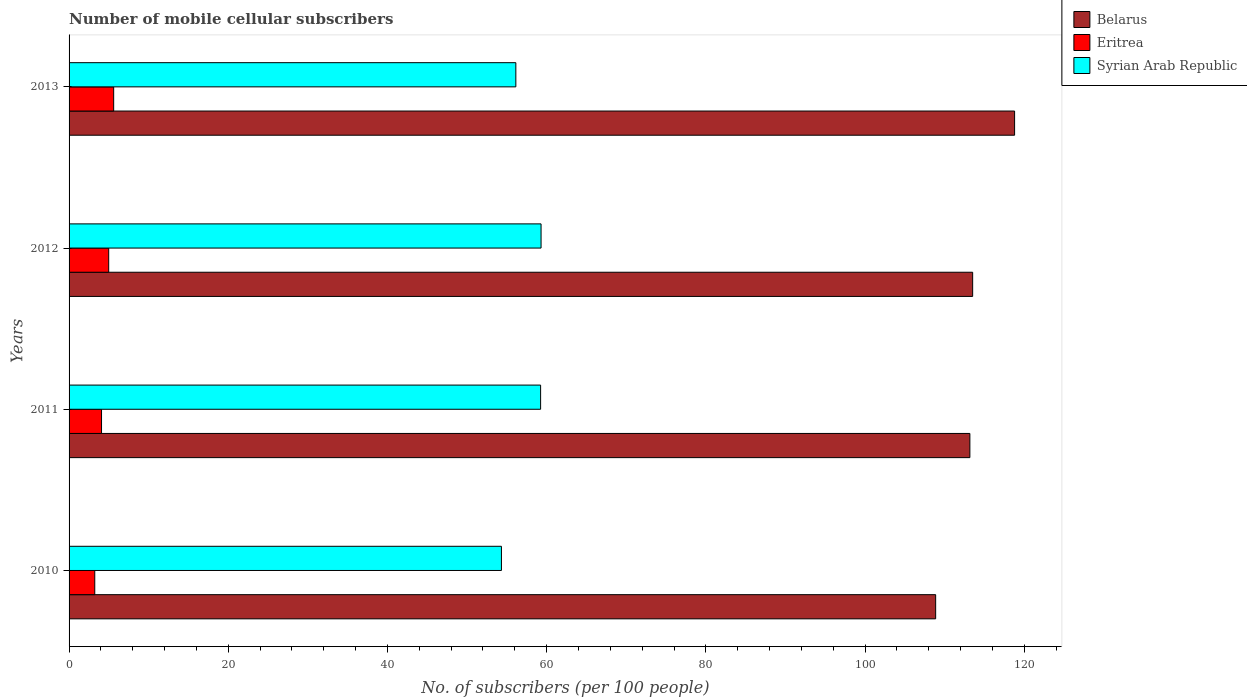How many groups of bars are there?
Offer a terse response. 4. Are the number of bars on each tick of the Y-axis equal?
Keep it short and to the point. Yes. How many bars are there on the 1st tick from the top?
Your answer should be very brief. 3. What is the label of the 3rd group of bars from the top?
Offer a terse response. 2011. What is the number of mobile cellular subscribers in Eritrea in 2012?
Your response must be concise. 4.98. Across all years, what is the maximum number of mobile cellular subscribers in Eritrea?
Ensure brevity in your answer.  5.6. Across all years, what is the minimum number of mobile cellular subscribers in Eritrea?
Keep it short and to the point. 3.23. In which year was the number of mobile cellular subscribers in Belarus minimum?
Ensure brevity in your answer.  2010. What is the total number of mobile cellular subscribers in Eritrea in the graph?
Your answer should be very brief. 17.89. What is the difference between the number of mobile cellular subscribers in Eritrea in 2010 and that in 2011?
Give a very brief answer. -0.85. What is the difference between the number of mobile cellular subscribers in Eritrea in 2011 and the number of mobile cellular subscribers in Belarus in 2013?
Offer a very short reply. -114.71. What is the average number of mobile cellular subscribers in Syrian Arab Republic per year?
Your answer should be compact. 57.25. In the year 2012, what is the difference between the number of mobile cellular subscribers in Belarus and number of mobile cellular subscribers in Syrian Arab Republic?
Offer a very short reply. 54.22. What is the ratio of the number of mobile cellular subscribers in Eritrea in 2010 to that in 2013?
Offer a terse response. 0.58. Is the number of mobile cellular subscribers in Belarus in 2010 less than that in 2011?
Provide a short and direct response. Yes. What is the difference between the highest and the second highest number of mobile cellular subscribers in Eritrea?
Ensure brevity in your answer.  0.62. What is the difference between the highest and the lowest number of mobile cellular subscribers in Syrian Arab Republic?
Offer a terse response. 4.98. In how many years, is the number of mobile cellular subscribers in Syrian Arab Republic greater than the average number of mobile cellular subscribers in Syrian Arab Republic taken over all years?
Your answer should be very brief. 2. What does the 2nd bar from the top in 2013 represents?
Provide a succinct answer. Eritrea. What does the 1st bar from the bottom in 2011 represents?
Ensure brevity in your answer.  Belarus. What is the difference between two consecutive major ticks on the X-axis?
Offer a very short reply. 20. Does the graph contain any zero values?
Keep it short and to the point. No. How are the legend labels stacked?
Offer a very short reply. Vertical. What is the title of the graph?
Your answer should be compact. Number of mobile cellular subscribers. What is the label or title of the X-axis?
Give a very brief answer. No. of subscribers (per 100 people). What is the No. of subscribers (per 100 people) in Belarus in 2010?
Make the answer very short. 108.87. What is the No. of subscribers (per 100 people) of Eritrea in 2010?
Offer a very short reply. 3.23. What is the No. of subscribers (per 100 people) in Syrian Arab Republic in 2010?
Make the answer very short. 54.32. What is the No. of subscribers (per 100 people) in Belarus in 2011?
Your answer should be very brief. 113.17. What is the No. of subscribers (per 100 people) of Eritrea in 2011?
Provide a succinct answer. 4.08. What is the No. of subscribers (per 100 people) in Syrian Arab Republic in 2011?
Offer a terse response. 59.24. What is the No. of subscribers (per 100 people) of Belarus in 2012?
Your answer should be very brief. 113.52. What is the No. of subscribers (per 100 people) in Eritrea in 2012?
Make the answer very short. 4.98. What is the No. of subscribers (per 100 people) of Syrian Arab Republic in 2012?
Give a very brief answer. 59.3. What is the No. of subscribers (per 100 people) of Belarus in 2013?
Provide a succinct answer. 118.79. What is the No. of subscribers (per 100 people) of Eritrea in 2013?
Provide a short and direct response. 5.6. What is the No. of subscribers (per 100 people) of Syrian Arab Republic in 2013?
Offer a terse response. 56.13. Across all years, what is the maximum No. of subscribers (per 100 people) in Belarus?
Give a very brief answer. 118.79. Across all years, what is the maximum No. of subscribers (per 100 people) of Eritrea?
Your response must be concise. 5.6. Across all years, what is the maximum No. of subscribers (per 100 people) in Syrian Arab Republic?
Your response must be concise. 59.3. Across all years, what is the minimum No. of subscribers (per 100 people) of Belarus?
Give a very brief answer. 108.87. Across all years, what is the minimum No. of subscribers (per 100 people) of Eritrea?
Provide a succinct answer. 3.23. Across all years, what is the minimum No. of subscribers (per 100 people) in Syrian Arab Republic?
Your answer should be compact. 54.32. What is the total No. of subscribers (per 100 people) of Belarus in the graph?
Keep it short and to the point. 454.34. What is the total No. of subscribers (per 100 people) of Eritrea in the graph?
Offer a terse response. 17.89. What is the total No. of subscribers (per 100 people) of Syrian Arab Republic in the graph?
Give a very brief answer. 228.98. What is the difference between the No. of subscribers (per 100 people) in Belarus in 2010 and that in 2011?
Provide a succinct answer. -4.3. What is the difference between the No. of subscribers (per 100 people) of Eritrea in 2010 and that in 2011?
Ensure brevity in your answer.  -0.85. What is the difference between the No. of subscribers (per 100 people) of Syrian Arab Republic in 2010 and that in 2011?
Offer a very short reply. -4.92. What is the difference between the No. of subscribers (per 100 people) of Belarus in 2010 and that in 2012?
Make the answer very short. -4.65. What is the difference between the No. of subscribers (per 100 people) in Eritrea in 2010 and that in 2012?
Offer a very short reply. -1.75. What is the difference between the No. of subscribers (per 100 people) of Syrian Arab Republic in 2010 and that in 2012?
Offer a very short reply. -4.98. What is the difference between the No. of subscribers (per 100 people) in Belarus in 2010 and that in 2013?
Your answer should be compact. -9.92. What is the difference between the No. of subscribers (per 100 people) of Eritrea in 2010 and that in 2013?
Your response must be concise. -2.38. What is the difference between the No. of subscribers (per 100 people) in Syrian Arab Republic in 2010 and that in 2013?
Your answer should be compact. -1.81. What is the difference between the No. of subscribers (per 100 people) of Belarus in 2011 and that in 2012?
Offer a terse response. -0.35. What is the difference between the No. of subscribers (per 100 people) in Eritrea in 2011 and that in 2012?
Provide a succinct answer. -0.9. What is the difference between the No. of subscribers (per 100 people) in Syrian Arab Republic in 2011 and that in 2012?
Your answer should be very brief. -0.06. What is the difference between the No. of subscribers (per 100 people) in Belarus in 2011 and that in 2013?
Your response must be concise. -5.62. What is the difference between the No. of subscribers (per 100 people) in Eritrea in 2011 and that in 2013?
Offer a terse response. -1.52. What is the difference between the No. of subscribers (per 100 people) of Syrian Arab Republic in 2011 and that in 2013?
Your answer should be compact. 3.11. What is the difference between the No. of subscribers (per 100 people) of Belarus in 2012 and that in 2013?
Your answer should be very brief. -5.27. What is the difference between the No. of subscribers (per 100 people) in Eritrea in 2012 and that in 2013?
Your response must be concise. -0.62. What is the difference between the No. of subscribers (per 100 people) in Syrian Arab Republic in 2012 and that in 2013?
Provide a short and direct response. 3.17. What is the difference between the No. of subscribers (per 100 people) in Belarus in 2010 and the No. of subscribers (per 100 people) in Eritrea in 2011?
Your answer should be very brief. 104.79. What is the difference between the No. of subscribers (per 100 people) of Belarus in 2010 and the No. of subscribers (per 100 people) of Syrian Arab Republic in 2011?
Keep it short and to the point. 49.63. What is the difference between the No. of subscribers (per 100 people) in Eritrea in 2010 and the No. of subscribers (per 100 people) in Syrian Arab Republic in 2011?
Offer a very short reply. -56.01. What is the difference between the No. of subscribers (per 100 people) of Belarus in 2010 and the No. of subscribers (per 100 people) of Eritrea in 2012?
Provide a short and direct response. 103.89. What is the difference between the No. of subscribers (per 100 people) in Belarus in 2010 and the No. of subscribers (per 100 people) in Syrian Arab Republic in 2012?
Provide a succinct answer. 49.57. What is the difference between the No. of subscribers (per 100 people) in Eritrea in 2010 and the No. of subscribers (per 100 people) in Syrian Arab Republic in 2012?
Keep it short and to the point. -56.07. What is the difference between the No. of subscribers (per 100 people) in Belarus in 2010 and the No. of subscribers (per 100 people) in Eritrea in 2013?
Keep it short and to the point. 103.27. What is the difference between the No. of subscribers (per 100 people) in Belarus in 2010 and the No. of subscribers (per 100 people) in Syrian Arab Republic in 2013?
Offer a very short reply. 52.74. What is the difference between the No. of subscribers (per 100 people) of Eritrea in 2010 and the No. of subscribers (per 100 people) of Syrian Arab Republic in 2013?
Ensure brevity in your answer.  -52.9. What is the difference between the No. of subscribers (per 100 people) of Belarus in 2011 and the No. of subscribers (per 100 people) of Eritrea in 2012?
Your response must be concise. 108.19. What is the difference between the No. of subscribers (per 100 people) in Belarus in 2011 and the No. of subscribers (per 100 people) in Syrian Arab Republic in 2012?
Your answer should be compact. 53.87. What is the difference between the No. of subscribers (per 100 people) of Eritrea in 2011 and the No. of subscribers (per 100 people) of Syrian Arab Republic in 2012?
Make the answer very short. -55.22. What is the difference between the No. of subscribers (per 100 people) of Belarus in 2011 and the No. of subscribers (per 100 people) of Eritrea in 2013?
Ensure brevity in your answer.  107.57. What is the difference between the No. of subscribers (per 100 people) of Belarus in 2011 and the No. of subscribers (per 100 people) of Syrian Arab Republic in 2013?
Offer a terse response. 57.04. What is the difference between the No. of subscribers (per 100 people) in Eritrea in 2011 and the No. of subscribers (per 100 people) in Syrian Arab Republic in 2013?
Give a very brief answer. -52.05. What is the difference between the No. of subscribers (per 100 people) in Belarus in 2012 and the No. of subscribers (per 100 people) in Eritrea in 2013?
Provide a short and direct response. 107.91. What is the difference between the No. of subscribers (per 100 people) in Belarus in 2012 and the No. of subscribers (per 100 people) in Syrian Arab Republic in 2013?
Your answer should be compact. 57.39. What is the difference between the No. of subscribers (per 100 people) of Eritrea in 2012 and the No. of subscribers (per 100 people) of Syrian Arab Republic in 2013?
Offer a terse response. -51.15. What is the average No. of subscribers (per 100 people) of Belarus per year?
Make the answer very short. 113.59. What is the average No. of subscribers (per 100 people) of Eritrea per year?
Give a very brief answer. 4.47. What is the average No. of subscribers (per 100 people) of Syrian Arab Republic per year?
Offer a terse response. 57.25. In the year 2010, what is the difference between the No. of subscribers (per 100 people) in Belarus and No. of subscribers (per 100 people) in Eritrea?
Your response must be concise. 105.64. In the year 2010, what is the difference between the No. of subscribers (per 100 people) in Belarus and No. of subscribers (per 100 people) in Syrian Arab Republic?
Your answer should be very brief. 54.55. In the year 2010, what is the difference between the No. of subscribers (per 100 people) of Eritrea and No. of subscribers (per 100 people) of Syrian Arab Republic?
Your response must be concise. -51.09. In the year 2011, what is the difference between the No. of subscribers (per 100 people) of Belarus and No. of subscribers (per 100 people) of Eritrea?
Provide a short and direct response. 109.09. In the year 2011, what is the difference between the No. of subscribers (per 100 people) in Belarus and No. of subscribers (per 100 people) in Syrian Arab Republic?
Make the answer very short. 53.93. In the year 2011, what is the difference between the No. of subscribers (per 100 people) in Eritrea and No. of subscribers (per 100 people) in Syrian Arab Republic?
Ensure brevity in your answer.  -55.16. In the year 2012, what is the difference between the No. of subscribers (per 100 people) of Belarus and No. of subscribers (per 100 people) of Eritrea?
Your answer should be compact. 108.54. In the year 2012, what is the difference between the No. of subscribers (per 100 people) of Belarus and No. of subscribers (per 100 people) of Syrian Arab Republic?
Provide a succinct answer. 54.22. In the year 2012, what is the difference between the No. of subscribers (per 100 people) in Eritrea and No. of subscribers (per 100 people) in Syrian Arab Republic?
Your answer should be compact. -54.32. In the year 2013, what is the difference between the No. of subscribers (per 100 people) of Belarus and No. of subscribers (per 100 people) of Eritrea?
Provide a short and direct response. 113.18. In the year 2013, what is the difference between the No. of subscribers (per 100 people) in Belarus and No. of subscribers (per 100 people) in Syrian Arab Republic?
Offer a terse response. 62.66. In the year 2013, what is the difference between the No. of subscribers (per 100 people) of Eritrea and No. of subscribers (per 100 people) of Syrian Arab Republic?
Keep it short and to the point. -50.53. What is the ratio of the No. of subscribers (per 100 people) in Eritrea in 2010 to that in 2011?
Ensure brevity in your answer.  0.79. What is the ratio of the No. of subscribers (per 100 people) in Syrian Arab Republic in 2010 to that in 2011?
Your answer should be compact. 0.92. What is the ratio of the No. of subscribers (per 100 people) in Belarus in 2010 to that in 2012?
Keep it short and to the point. 0.96. What is the ratio of the No. of subscribers (per 100 people) of Eritrea in 2010 to that in 2012?
Ensure brevity in your answer.  0.65. What is the ratio of the No. of subscribers (per 100 people) in Syrian Arab Republic in 2010 to that in 2012?
Your answer should be compact. 0.92. What is the ratio of the No. of subscribers (per 100 people) in Belarus in 2010 to that in 2013?
Offer a terse response. 0.92. What is the ratio of the No. of subscribers (per 100 people) in Eritrea in 2010 to that in 2013?
Give a very brief answer. 0.58. What is the ratio of the No. of subscribers (per 100 people) of Eritrea in 2011 to that in 2012?
Keep it short and to the point. 0.82. What is the ratio of the No. of subscribers (per 100 people) of Belarus in 2011 to that in 2013?
Offer a very short reply. 0.95. What is the ratio of the No. of subscribers (per 100 people) of Eritrea in 2011 to that in 2013?
Provide a succinct answer. 0.73. What is the ratio of the No. of subscribers (per 100 people) in Syrian Arab Republic in 2011 to that in 2013?
Provide a short and direct response. 1.06. What is the ratio of the No. of subscribers (per 100 people) of Belarus in 2012 to that in 2013?
Your answer should be very brief. 0.96. What is the ratio of the No. of subscribers (per 100 people) of Eritrea in 2012 to that in 2013?
Offer a terse response. 0.89. What is the ratio of the No. of subscribers (per 100 people) of Syrian Arab Republic in 2012 to that in 2013?
Provide a short and direct response. 1.06. What is the difference between the highest and the second highest No. of subscribers (per 100 people) in Belarus?
Keep it short and to the point. 5.27. What is the difference between the highest and the second highest No. of subscribers (per 100 people) in Eritrea?
Your answer should be very brief. 0.62. What is the difference between the highest and the second highest No. of subscribers (per 100 people) in Syrian Arab Republic?
Give a very brief answer. 0.06. What is the difference between the highest and the lowest No. of subscribers (per 100 people) of Belarus?
Ensure brevity in your answer.  9.92. What is the difference between the highest and the lowest No. of subscribers (per 100 people) of Eritrea?
Make the answer very short. 2.38. What is the difference between the highest and the lowest No. of subscribers (per 100 people) in Syrian Arab Republic?
Provide a succinct answer. 4.98. 